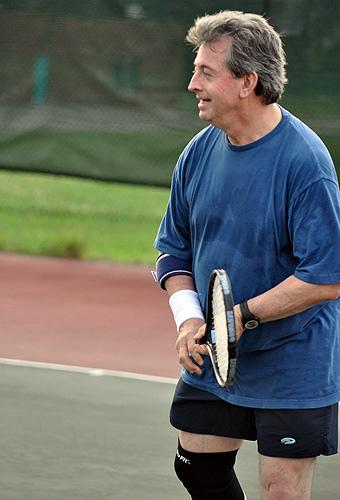What color is the man's shirt?
Short answer required. Blue. Is he in motion?
Answer briefly. No. What color is this man's shirt?
Give a very brief answer. Blue. Is he dressed in blue?
Be succinct. Yes. Does he look happy?
Short answer required. Yes. Is he moving fast?
Write a very short answer. No. Is the player wearing an Adidas outfit?
Keep it brief. No. 